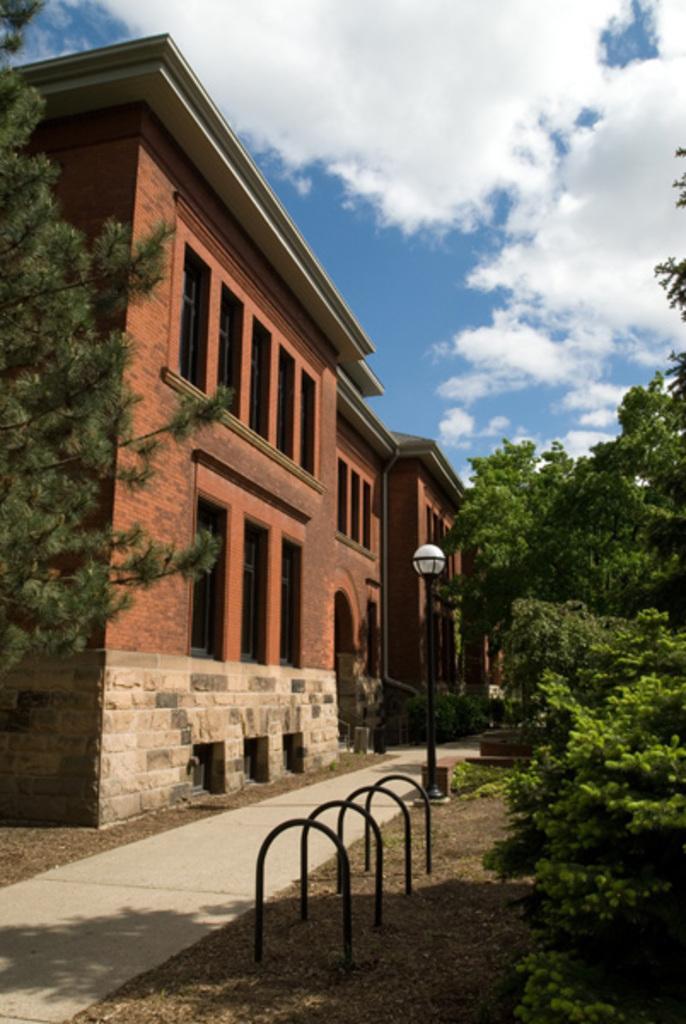Can you describe this image briefly? It looks like a huge university it has many windows and doors, in front of the university there are a lot of trees and plants and on the right side there is a pole light and in the background there is a sky. 